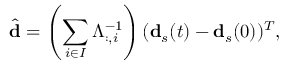<formula> <loc_0><loc_0><loc_500><loc_500>\hat { d } = \left ( \sum _ { i \in I } { \Lambda _ { \colon , i } ^ { - 1 } } \right ) ( d _ { s } ( t ) - d _ { s } ( 0 ) ) ^ { T } ,</formula> 